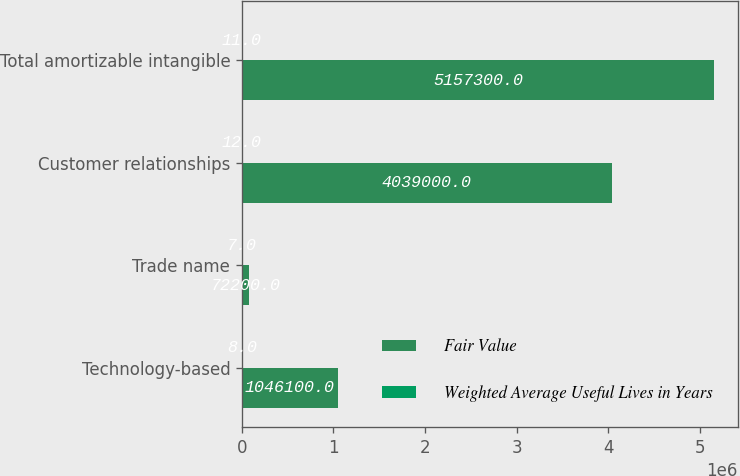Convert chart to OTSL. <chart><loc_0><loc_0><loc_500><loc_500><stacked_bar_chart><ecel><fcel>Technology-based<fcel>Trade name<fcel>Customer relationships<fcel>Total amortizable intangible<nl><fcel>Fair Value<fcel>1.0461e+06<fcel>72200<fcel>4.039e+06<fcel>5.1573e+06<nl><fcel>Weighted Average Useful Lives in Years<fcel>8<fcel>7<fcel>12<fcel>11<nl></chart> 